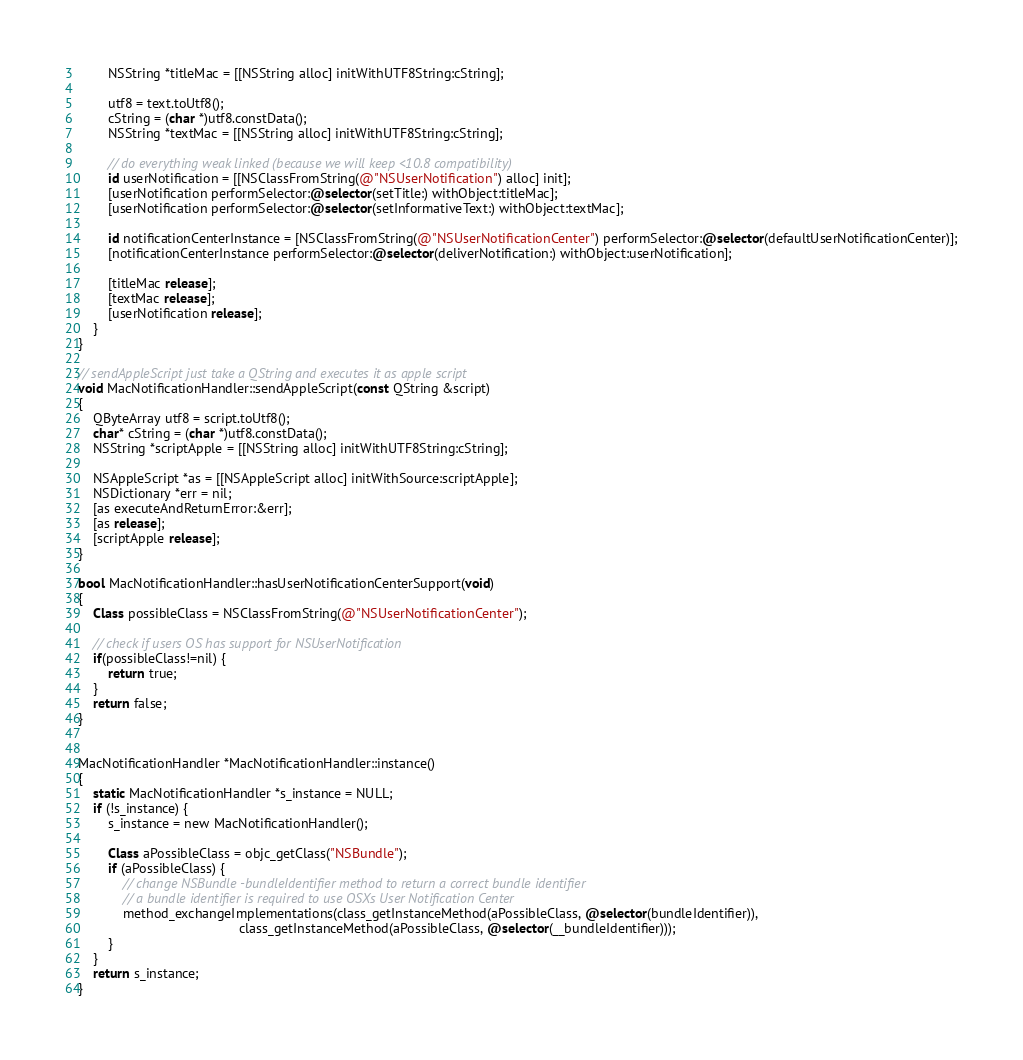Convert code to text. <code><loc_0><loc_0><loc_500><loc_500><_ObjectiveC_>        NSString *titleMac = [[NSString alloc] initWithUTF8String:cString];

        utf8 = text.toUtf8();
        cString = (char *)utf8.constData();
        NSString *textMac = [[NSString alloc] initWithUTF8String:cString];

        // do everything weak linked (because we will keep <10.8 compatibility)
        id userNotification = [[NSClassFromString(@"NSUserNotification") alloc] init];
        [userNotification performSelector:@selector(setTitle:) withObject:titleMac];
        [userNotification performSelector:@selector(setInformativeText:) withObject:textMac];

        id notificationCenterInstance = [NSClassFromString(@"NSUserNotificationCenter") performSelector:@selector(defaultUserNotificationCenter)];
        [notificationCenterInstance performSelector:@selector(deliverNotification:) withObject:userNotification];

        [titleMac release];
        [textMac release];
        [userNotification release];
    }
}

// sendAppleScript just take a QString and executes it as apple script
void MacNotificationHandler::sendAppleScript(const QString &script)
{
    QByteArray utf8 = script.toUtf8();
    char* cString = (char *)utf8.constData();
    NSString *scriptApple = [[NSString alloc] initWithUTF8String:cString];

    NSAppleScript *as = [[NSAppleScript alloc] initWithSource:scriptApple];
    NSDictionary *err = nil;
    [as executeAndReturnError:&err];
    [as release];
    [scriptApple release];
}

bool MacNotificationHandler::hasUserNotificationCenterSupport(void)
{
    Class possibleClass = NSClassFromString(@"NSUserNotificationCenter");

    // check if users OS has support for NSUserNotification
    if(possibleClass!=nil) {
        return true;
    }
    return false;
}


MacNotificationHandler *MacNotificationHandler::instance()
{
    static MacNotificationHandler *s_instance = NULL;
    if (!s_instance) {
        s_instance = new MacNotificationHandler();
        
        Class aPossibleClass = objc_getClass("NSBundle");
        if (aPossibleClass) {
            // change NSBundle -bundleIdentifier method to return a correct bundle identifier
            // a bundle identifier is required to use OSXs User Notification Center
            method_exchangeImplementations(class_getInstanceMethod(aPossibleClass, @selector(bundleIdentifier)),
                                           class_getInstanceMethod(aPossibleClass, @selector(__bundleIdentifier)));
        }
    }
    return s_instance;
}
</code> 